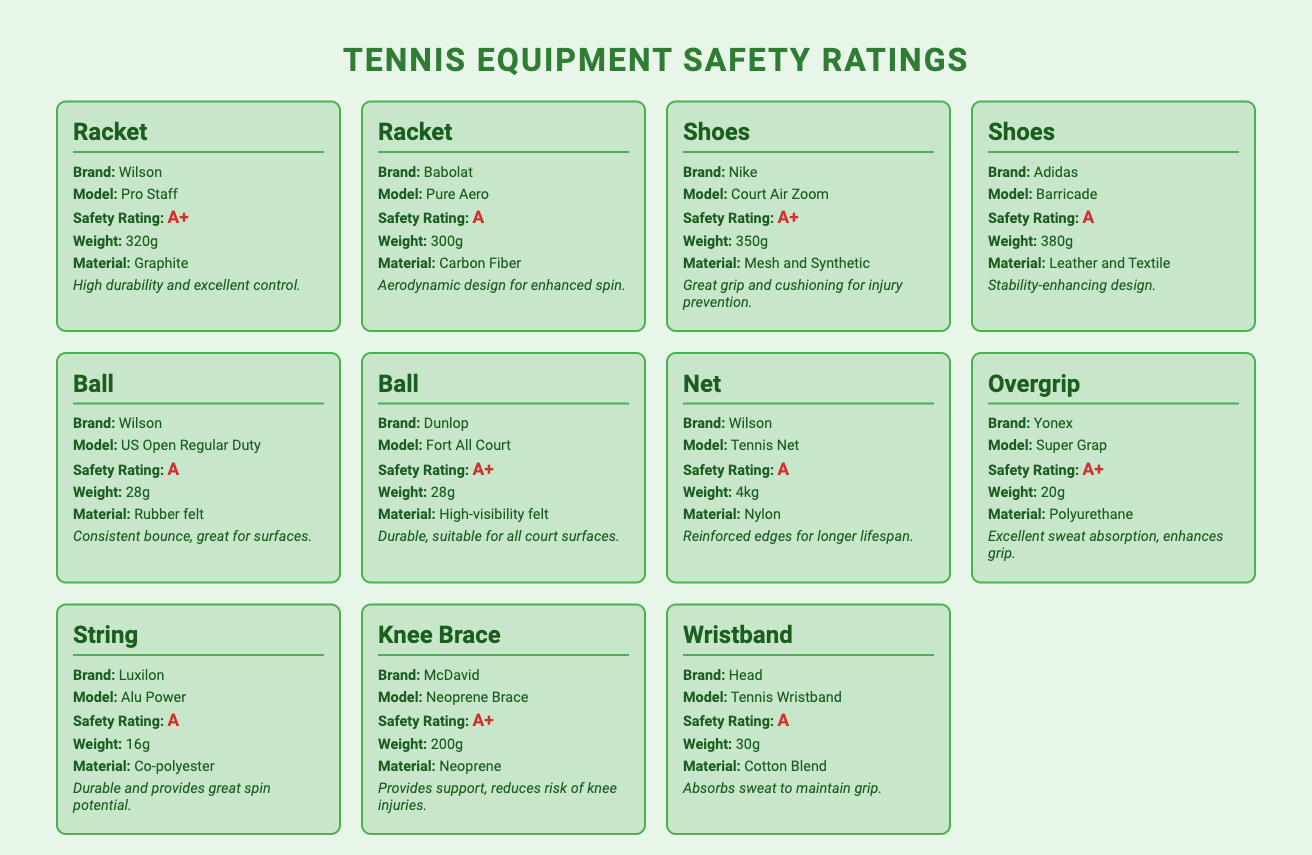What is the Safety Rating of the Wilson Pro Staff racket? The safety rating for the Wilson Pro Staff racket is directly listed in the table, which shows "A+" as its safety rating.
Answer: A+ Which tennis ball has the highest safety rating? Looking at the safety ratings listed, the Dunlop Fort All Court ball has an "A+" rating, which is higher than all other balls listed.
Answer: Dunlop Fort All Court What is the weight difference between the lightest and heaviest shoes? The lightest shoe is the Nike Court Air Zoom at 350g, and the heaviest is the Adidas Barricade at 380g. The difference is calculated as 380g - 350g = 30g.
Answer: 30g Do all of the rackets listed have a safety rating of A or higher? Both rackets listed, the Wilson Pro Staff and Babolat Pure Aero, have safety ratings of "A+" and "A" respectively, so yes, they both meet the criterion of having a safety rating of A or higher.
Answer: Yes How many items in the table have a safety rating of A+? Counting the items with a rating of A+, we find the Wilson Pro Staff racket, Nike Court Air Zoom shoes, Dunlop Fort All Court ball, Yonex Super Grap overgrip, McDavid Neoprene Brace, totaling 5 items.
Answer: 5 